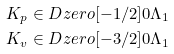Convert formula to latex. <formula><loc_0><loc_0><loc_500><loc_500>K _ { p } & \in \L D z e r o [ - 1 / 2 ] { 0 } { \Lambda _ { 1 } } \\ K _ { v } & \in \L D z e r o [ - 3 / 2 ] { 0 } { \Lambda _ { 1 } }</formula> 